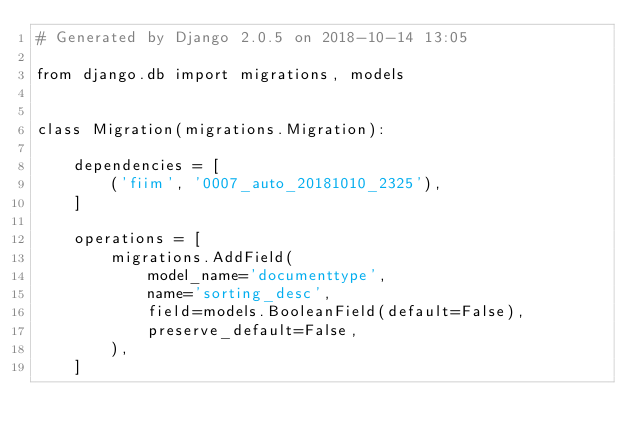<code> <loc_0><loc_0><loc_500><loc_500><_Python_># Generated by Django 2.0.5 on 2018-10-14 13:05

from django.db import migrations, models


class Migration(migrations.Migration):

    dependencies = [
        ('fiim', '0007_auto_20181010_2325'),
    ]

    operations = [
        migrations.AddField(
            model_name='documenttype',
            name='sorting_desc',
            field=models.BooleanField(default=False),
            preserve_default=False,
        ),
    ]
</code> 